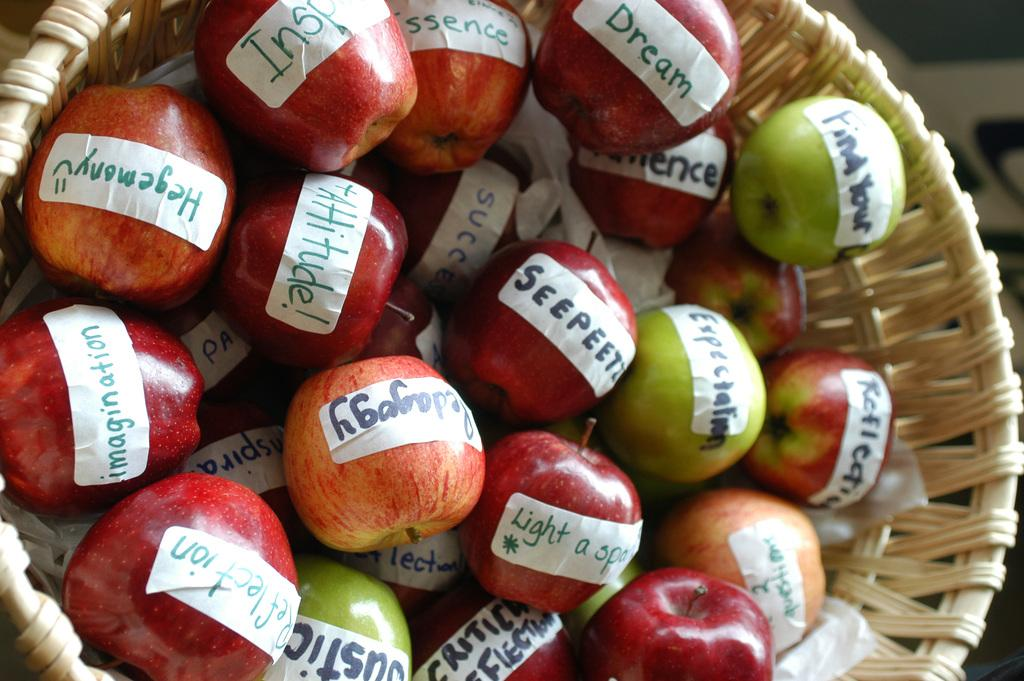What type of fruit is present in the image? There are apples in the image. How are the apples arranged or contained in the image? The apples are in a basket. What type of button can be seen on the apples in the image? There are no buttons present on the apples in the image. How many times do the apples smash into each other in the image? The apples are not shown smashing into each other in the image; they are in a basket. 